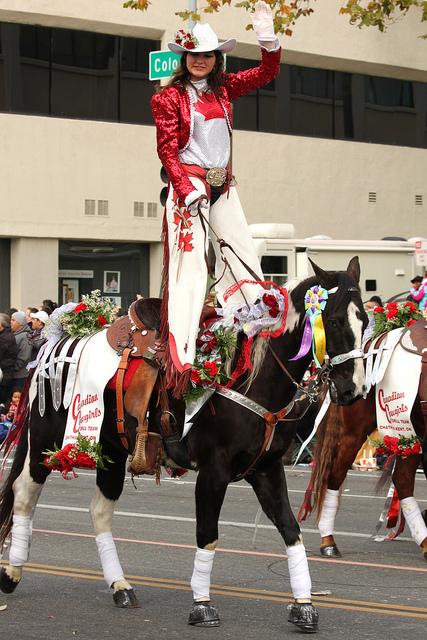What color is the horse?
Short answer required. Black. Is the horse in a parade?
Be succinct. Yes. Is this woman standing?
Answer briefly. Yes. 